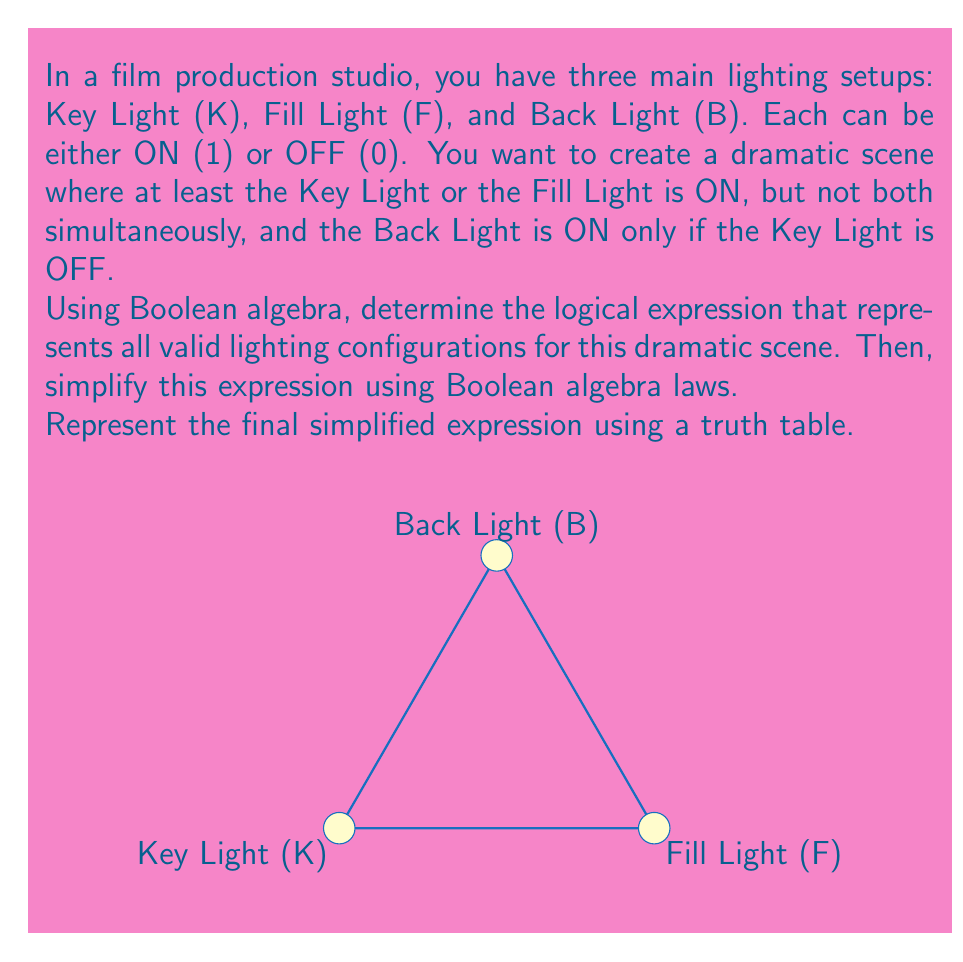Give your solution to this math problem. Let's approach this step-by-step:

1) First, let's express the conditions in Boolean algebra:
   - At least K or F is ON, but not both: $(K \oplus F)$
   - B is ON only if K is OFF: $(\overline{K} \land B)$

2) The complete expression is:
   $$(K \oplus F) \land (\overline{K} \lor \overline{B})$$

3) Let's simplify this expression:
   $$(K \oplus F) \land (\overline{K} \lor \overline{B})$$
   $$= ((K \land \overline{F}) \lor (\overline{K} \land F)) \land (\overline{K} \lor \overline{B})$$
   
4) Using the distributive law:
   $$= (K \land \overline{F} \land \overline{K}) \lor (K \land \overline{F} \land \overline{B}) \lor (\overline{K} \land F \land \overline{K}) \lor (\overline{K} \land F \land \overline{B})$$

5) Simplify:
   - $(K \land \overline{F} \land \overline{K}) = 0$ (contradiction)
   - $(\overline{K} \land F \land \overline{K}) = (\overline{K} \land F)$
   
   So, we're left with:
   $$(K \land \overline{F} \land \overline{B}) \lor (\overline{K} \land F \land \overline{B}) \lor (\overline{K} \land F)$$

6) Factor out $(\overline{K} \land F)$:
   $$(K \land \overline{F} \land \overline{B}) \lor (\overline{K} \land F \land (\overline{B} \lor 1))$$
   $$= (K \land \overline{F} \land \overline{B}) \lor (\overline{K} \land F)$$

This is our simplified expression. Now, let's represent it as a truth table:

| K | F | B | Result |
|---|---|---|--------|
| 0 | 0 | 0 |   0    |
| 0 | 0 | 1 |   0    |
| 0 | 1 | 0 |   1    |
| 0 | 1 | 1 |   1    |
| 1 | 0 | 0 |   1    |
| 1 | 0 | 1 |   0    |
| 1 | 1 | 0 |   0    |
| 1 | 1 | 1 |   0    |
Answer: $(K \land \overline{F} \land \overline{B}) \lor (\overline{K} \land F)$ 